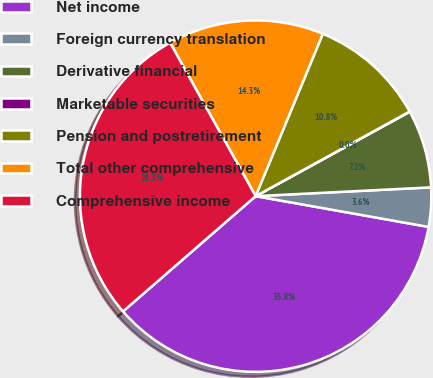Convert chart. <chart><loc_0><loc_0><loc_500><loc_500><pie_chart><fcel>Net income<fcel>Foreign currency translation<fcel>Derivative financial<fcel>Marketable securities<fcel>Pension and postretirement<fcel>Total other comprehensive<fcel>Comprehensive income<nl><fcel>35.81%<fcel>3.6%<fcel>7.18%<fcel>0.02%<fcel>10.76%<fcel>14.34%<fcel>28.3%<nl></chart> 